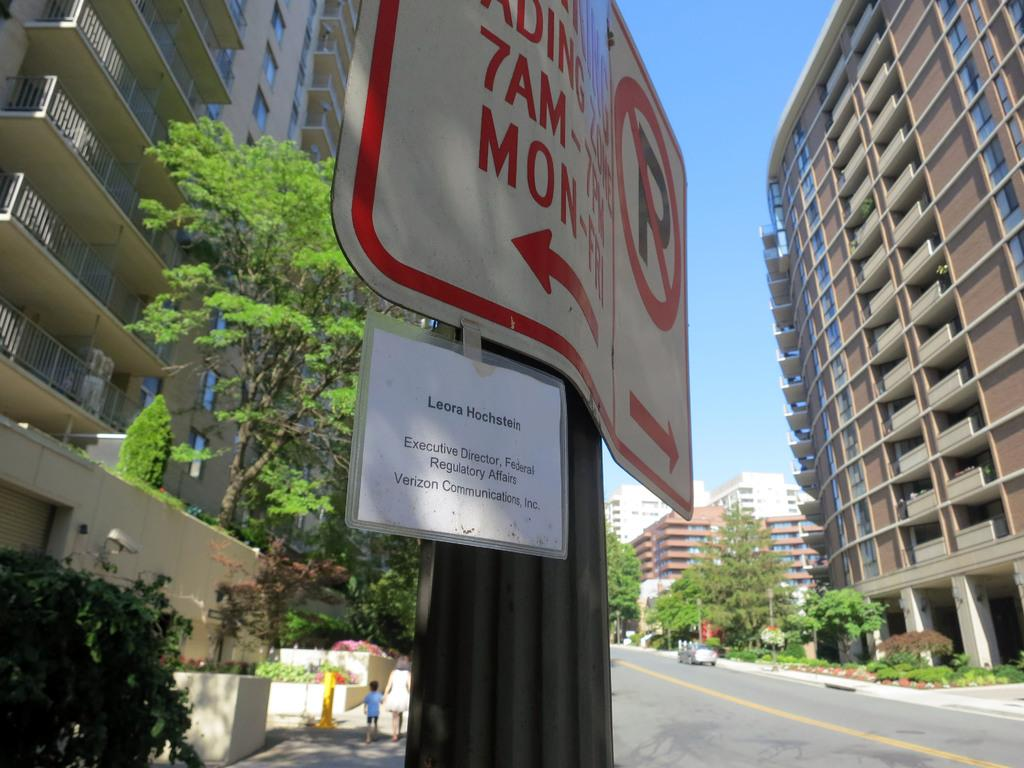What type of structures can be seen in the image? There are buildings in the image. What feature do the buildings have? The buildings have glass windows. What can be seen near the buildings? There are railings, trees, poles, and signboards in the image. What mode of transportation is present in the image? There are vehicles in the image. What activity are people engaged in? There are people walking on the road in the image. What is the color of the sky in the image? The sky is blue and white in color. Where are the tomatoes and pickles located in the image? There are no tomatoes or pickles present in the image. 